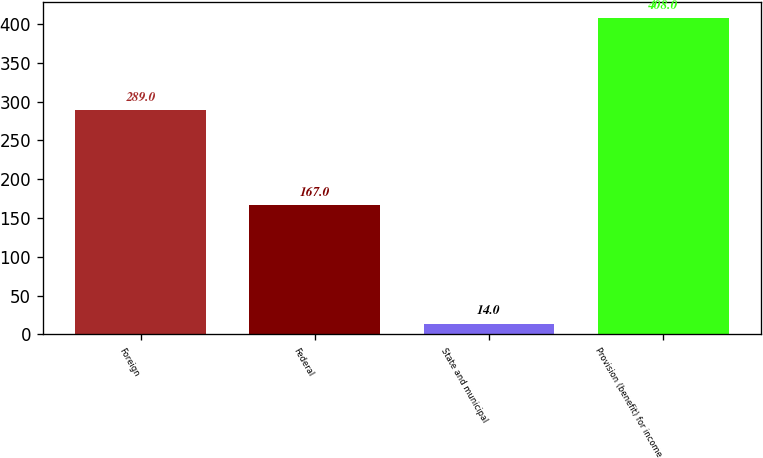Convert chart to OTSL. <chart><loc_0><loc_0><loc_500><loc_500><bar_chart><fcel>Foreign<fcel>Federal<fcel>State and municipal<fcel>Provision (benefit) for income<nl><fcel>289<fcel>167<fcel>14<fcel>408<nl></chart> 